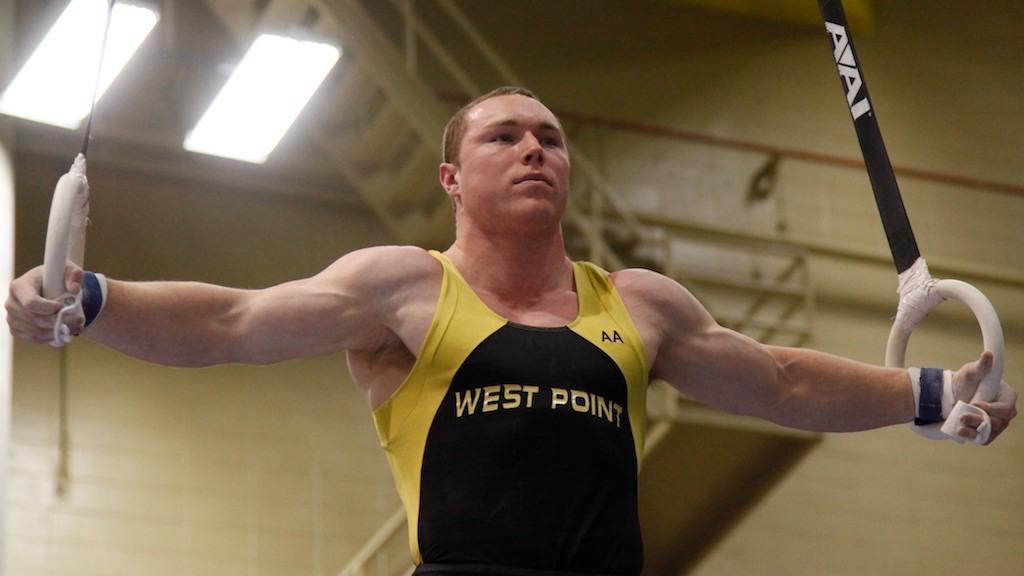What does his tank top say?
Keep it short and to the point. West point. What letter is on the right on the yellow part of the tank top?
Offer a very short reply. A. 